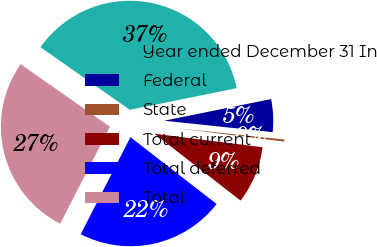<chart> <loc_0><loc_0><loc_500><loc_500><pie_chart><fcel>Year ended December 31 In<fcel>Federal<fcel>State<fcel>Total current<fcel>Total deferred<fcel>Total<nl><fcel>37.09%<fcel>4.85%<fcel>0.31%<fcel>8.52%<fcel>22.04%<fcel>27.19%<nl></chart> 